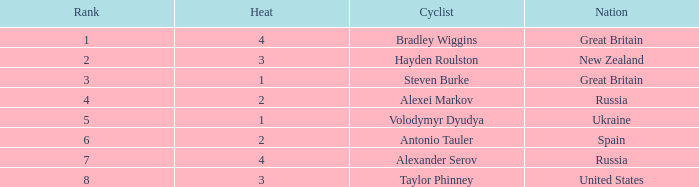What is the lowest rank that spain got? 6.0. 